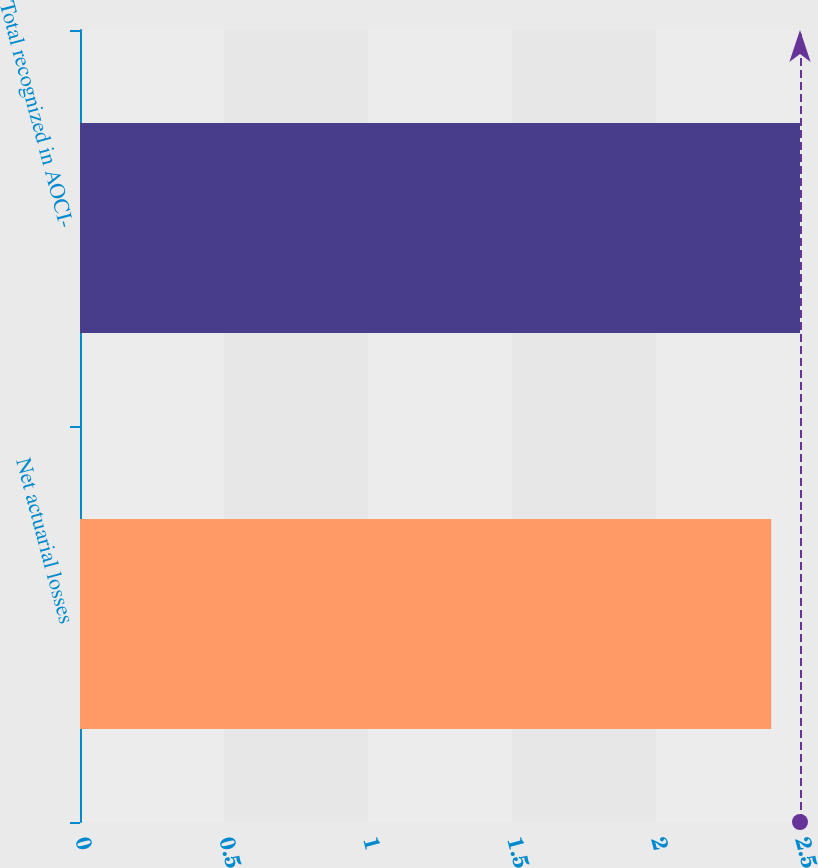Convert chart. <chart><loc_0><loc_0><loc_500><loc_500><bar_chart><fcel>Net actuarial losses<fcel>Total recognized in AOCI-<nl><fcel>2.4<fcel>2.5<nl></chart> 